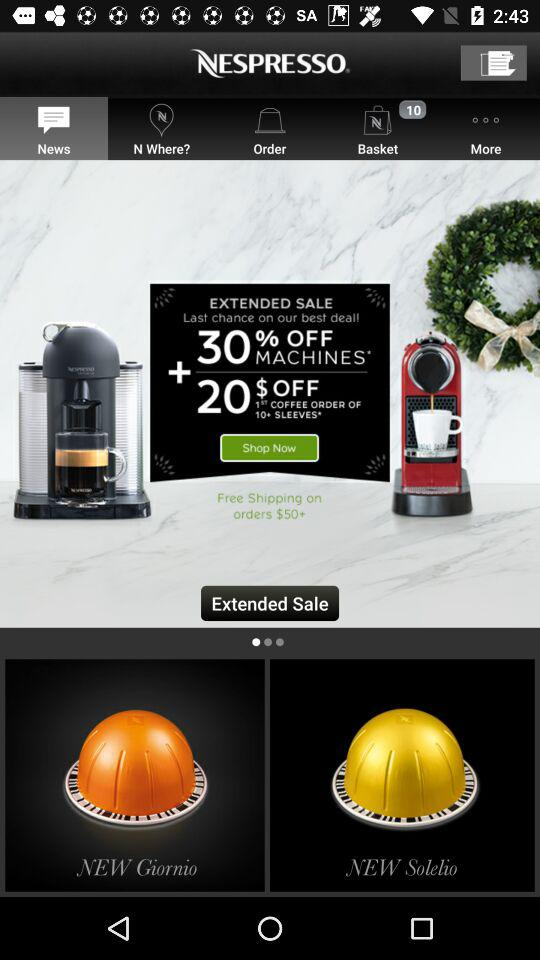Which tab is selected? The selected tab is "News". 